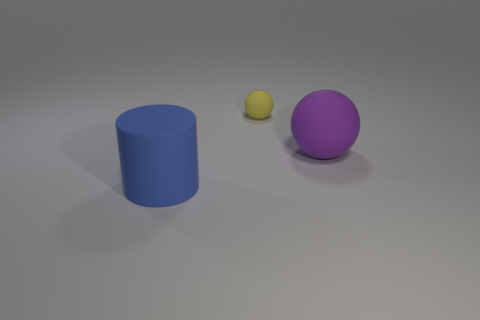There is a large thing left of the rubber thing that is behind the matte object to the right of the small yellow rubber ball; what color is it? blue 